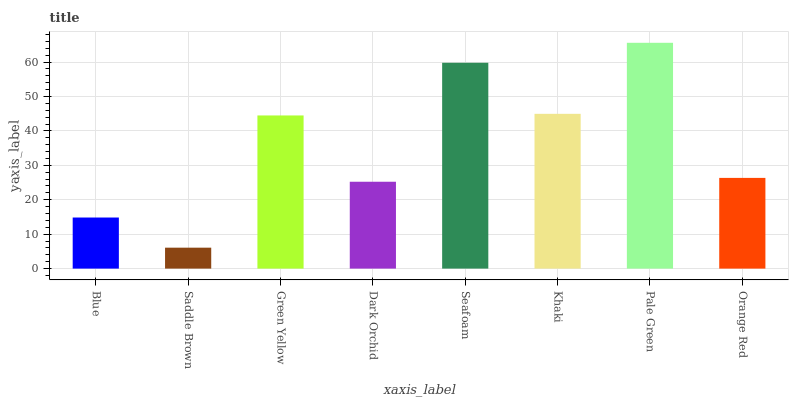Is Saddle Brown the minimum?
Answer yes or no. Yes. Is Pale Green the maximum?
Answer yes or no. Yes. Is Green Yellow the minimum?
Answer yes or no. No. Is Green Yellow the maximum?
Answer yes or no. No. Is Green Yellow greater than Saddle Brown?
Answer yes or no. Yes. Is Saddle Brown less than Green Yellow?
Answer yes or no. Yes. Is Saddle Brown greater than Green Yellow?
Answer yes or no. No. Is Green Yellow less than Saddle Brown?
Answer yes or no. No. Is Green Yellow the high median?
Answer yes or no. Yes. Is Orange Red the low median?
Answer yes or no. Yes. Is Pale Green the high median?
Answer yes or no. No. Is Pale Green the low median?
Answer yes or no. No. 